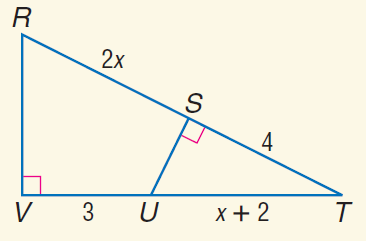Answer the mathemtical geometry problem and directly provide the correct option letter.
Question: Find x.
Choices: A: 3 B: 4 C: 5 D: 6 A 